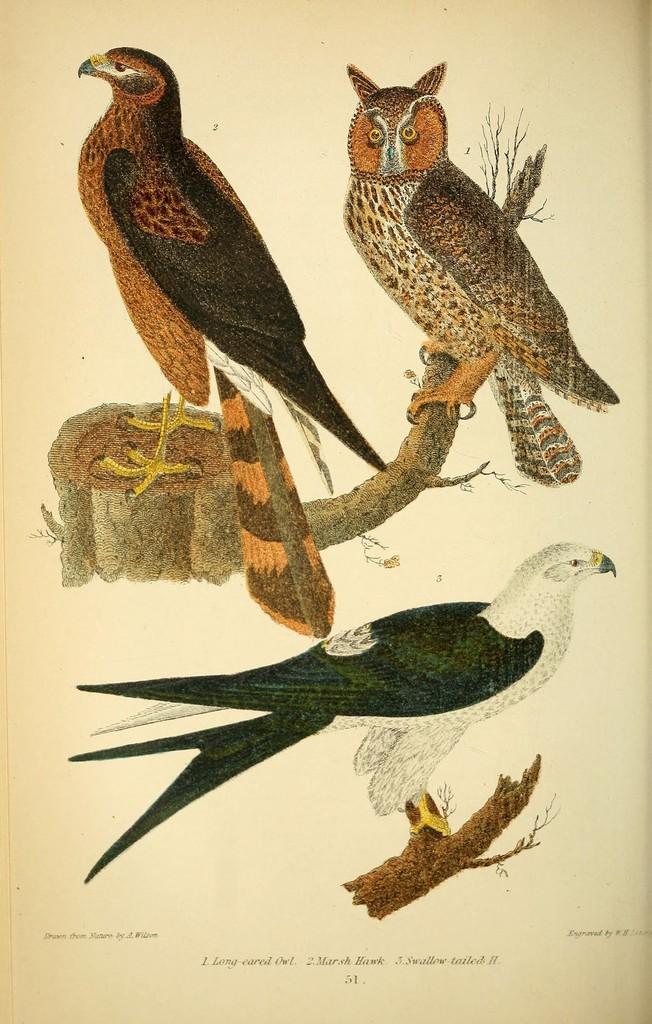In one or two sentences, can you explain what this image depicts? In this image we can see the pictures of some birds. On the bottom of the image we can see some text. 